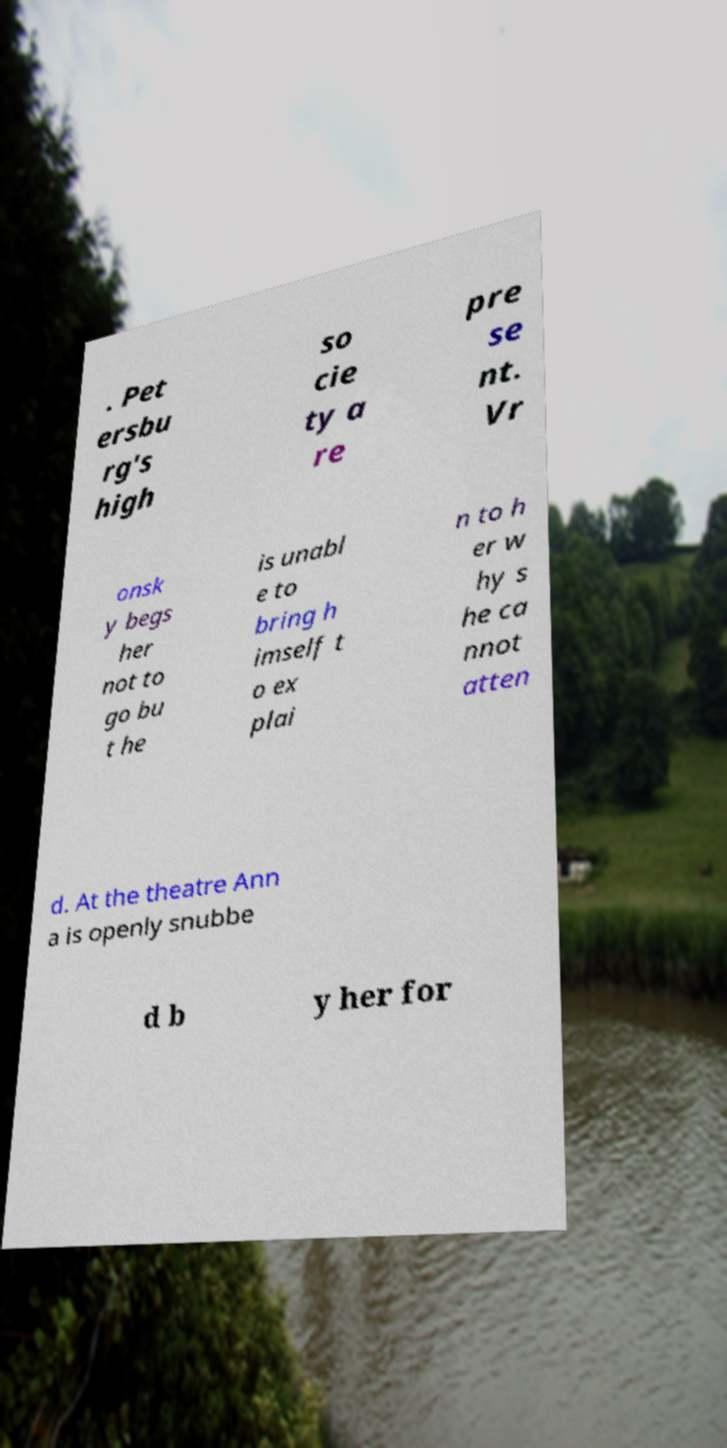Please read and relay the text visible in this image. What does it say? . Pet ersbu rg's high so cie ty a re pre se nt. Vr onsk y begs her not to go bu t he is unabl e to bring h imself t o ex plai n to h er w hy s he ca nnot atten d. At the theatre Ann a is openly snubbe d b y her for 